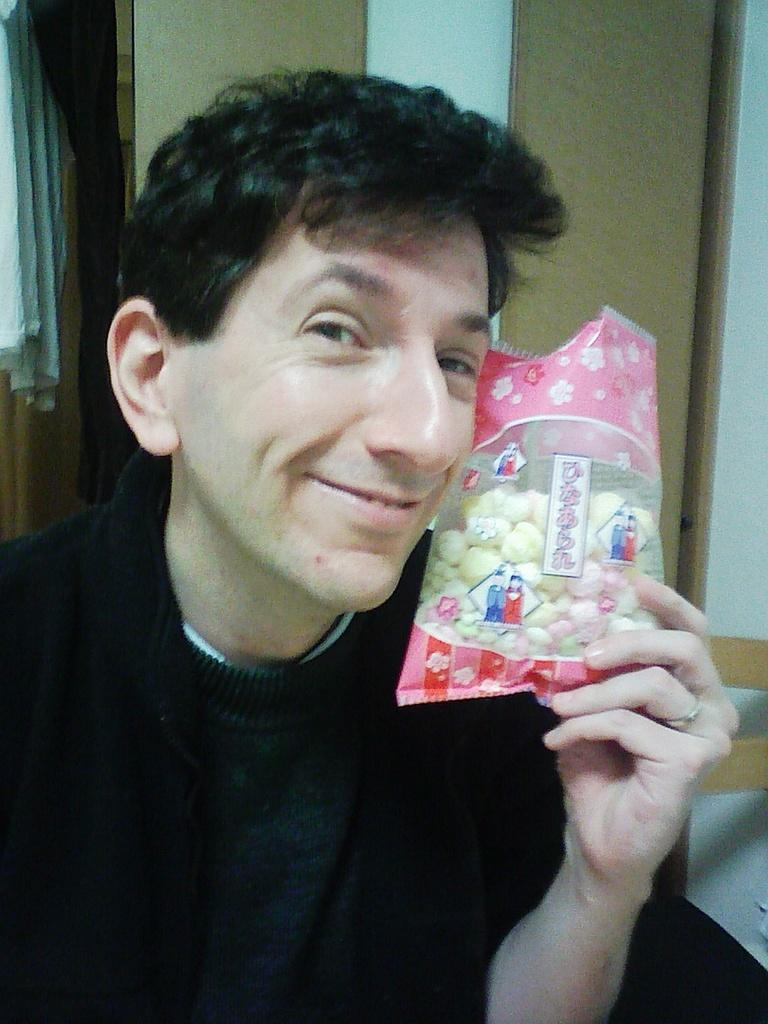What is the person in the image holding? The person is holding a cover in the image. What can be found inside the cover? There are objects inside the cover. What can be seen in the background of the image? There is a wall and a white color cloth in the background of the image. Can you tell me how many frogs are sitting on the queen's lizards in the image? There are no frogs, queens, or lizards present in the image. 